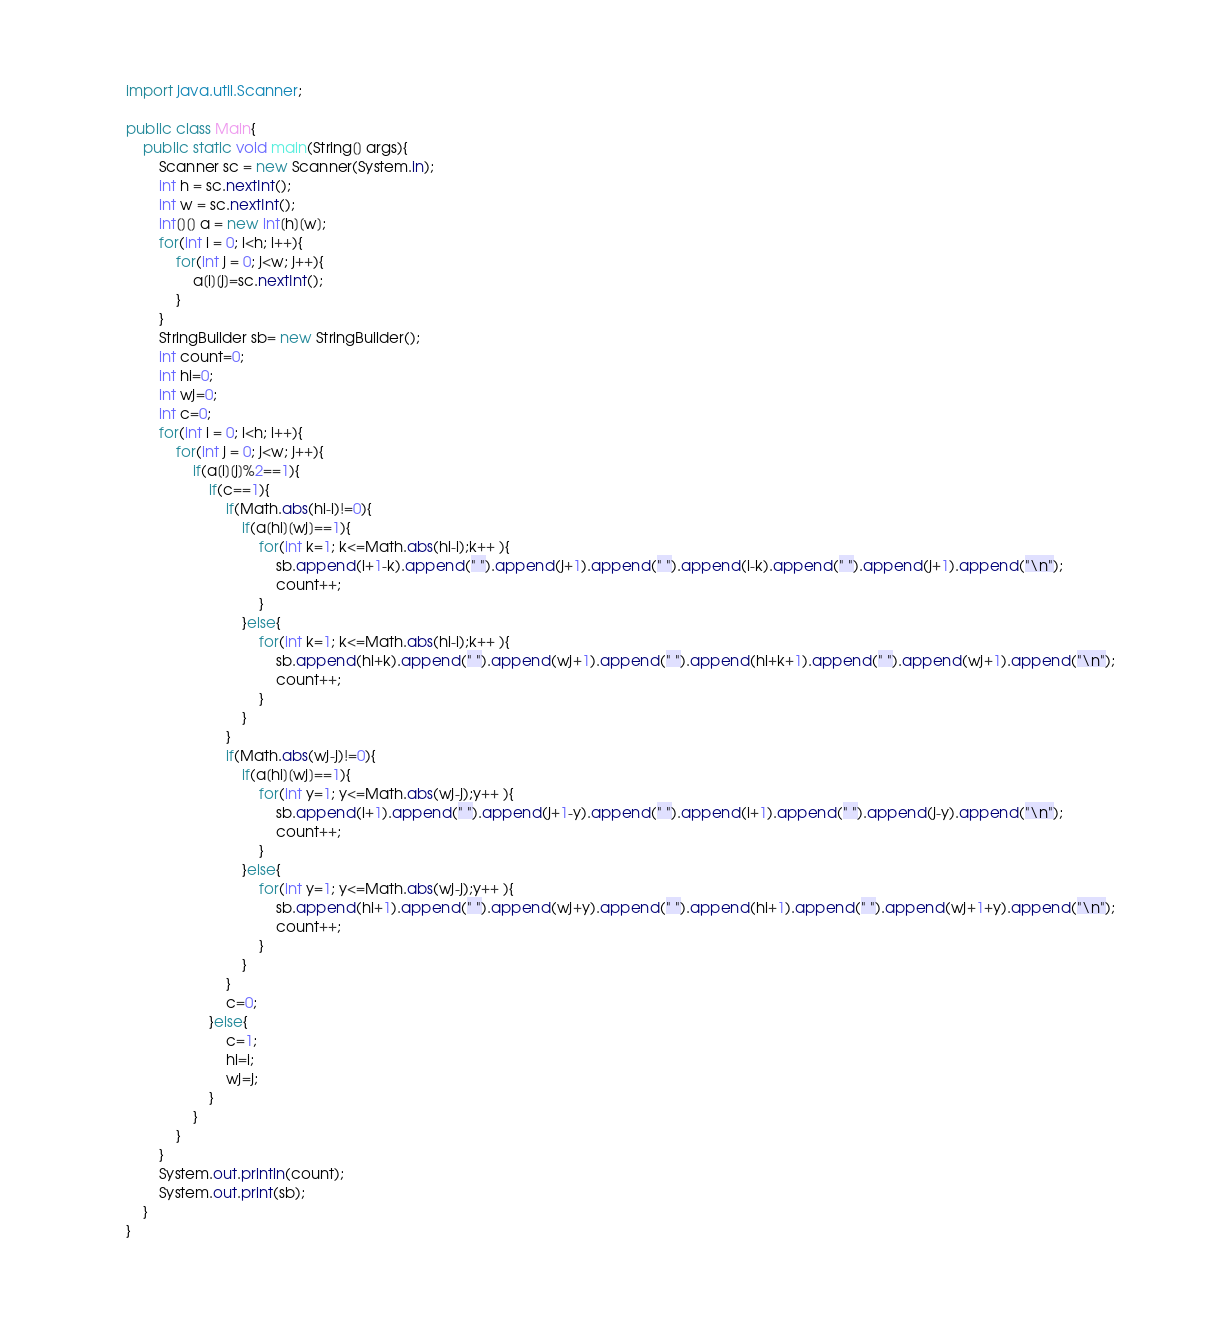<code> <loc_0><loc_0><loc_500><loc_500><_Java_>import java.util.Scanner;

public class Main{
	public static void main(String[] args){
		Scanner sc = new Scanner(System.in);
		int h = sc.nextInt();
		int w = sc.nextInt();
		int[][] a = new int[h][w];
		for(int i = 0; i<h; i++){
			for(int j = 0; j<w; j++){
				a[i][j]=sc.nextInt();
			}
		}
		StringBuilder sb= new StringBuilder();
		int count=0;
		int hi=0;
		int wj=0;
		int c=0;
		for(int i = 0; i<h; i++){
			for(int j = 0; j<w; j++){
				if(a[i][j]%2==1){
					if(c==1){
						if(Math.abs(hi-i)!=0){
							if(a[hi][wj]==1){
								for(int k=1; k<=Math.abs(hi-i);k++ ){
									sb.append(i+1-k).append(" ").append(j+1).append(" ").append(i-k).append(" ").append(j+1).append("\n");	
									count++;
								}
							}else{
								for(int k=1; k<=Math.abs(hi-i);k++ ){
									sb.append(hi+k).append(" ").append(wj+1).append(" ").append(hi+k+1).append(" ").append(wj+1).append("\n");	
									count++;
								}
							}
						}
						if(Math.abs(wj-j)!=0){
							if(a[hi][wj]==1){
								for(int y=1; y<=Math.abs(wj-j);y++ ){
									sb.append(i+1).append(" ").append(j+1-y).append(" ").append(i+1).append(" ").append(j-y).append("\n");	
									count++;
								}
							}else{
								for(int y=1; y<=Math.abs(wj-j);y++ ){
									sb.append(hi+1).append(" ").append(wj+y).append(" ").append(hi+1).append(" ").append(wj+1+y).append("\n");	
									count++;
								}
							}
						}
						c=0;
					}else{
						c=1;
						hi=i;
						wj=j;
					}
				}
			}
		}
		System.out.println(count);
		System.out.print(sb);
	}
}</code> 